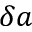<formula> <loc_0><loc_0><loc_500><loc_500>\delta a</formula> 